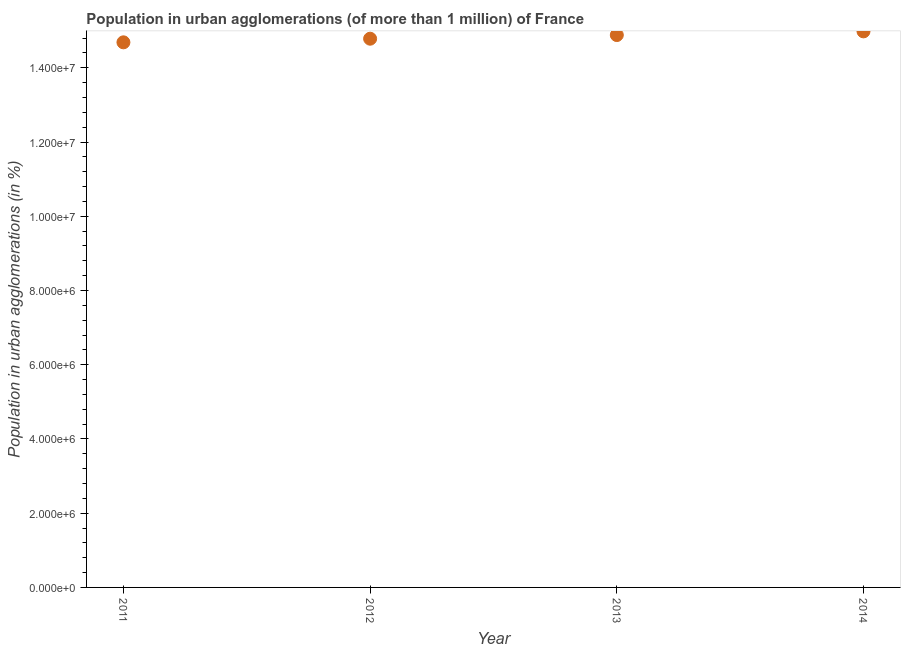What is the population in urban agglomerations in 2012?
Make the answer very short. 1.48e+07. Across all years, what is the maximum population in urban agglomerations?
Offer a very short reply. 1.50e+07. Across all years, what is the minimum population in urban agglomerations?
Offer a very short reply. 1.47e+07. In which year was the population in urban agglomerations maximum?
Provide a short and direct response. 2014. What is the sum of the population in urban agglomerations?
Ensure brevity in your answer.  5.93e+07. What is the difference between the population in urban agglomerations in 2011 and 2013?
Your answer should be compact. -1.96e+05. What is the average population in urban agglomerations per year?
Offer a very short reply. 1.48e+07. What is the median population in urban agglomerations?
Give a very brief answer. 1.48e+07. In how many years, is the population in urban agglomerations greater than 2800000 %?
Keep it short and to the point. 4. Do a majority of the years between 2013 and 2014 (inclusive) have population in urban agglomerations greater than 10400000 %?
Give a very brief answer. Yes. What is the ratio of the population in urban agglomerations in 2012 to that in 2013?
Offer a terse response. 0.99. What is the difference between the highest and the second highest population in urban agglomerations?
Your response must be concise. 9.91e+04. Is the sum of the population in urban agglomerations in 2011 and 2014 greater than the maximum population in urban agglomerations across all years?
Provide a short and direct response. Yes. What is the difference between the highest and the lowest population in urban agglomerations?
Your answer should be compact. 2.95e+05. How many dotlines are there?
Your response must be concise. 1. What is the difference between two consecutive major ticks on the Y-axis?
Provide a short and direct response. 2.00e+06. Are the values on the major ticks of Y-axis written in scientific E-notation?
Provide a succinct answer. Yes. Does the graph contain any zero values?
Make the answer very short. No. Does the graph contain grids?
Provide a succinct answer. No. What is the title of the graph?
Offer a terse response. Population in urban agglomerations (of more than 1 million) of France. What is the label or title of the Y-axis?
Offer a terse response. Population in urban agglomerations (in %). What is the Population in urban agglomerations (in %) in 2011?
Your answer should be compact. 1.47e+07. What is the Population in urban agglomerations (in %) in 2012?
Give a very brief answer. 1.48e+07. What is the Population in urban agglomerations (in %) in 2013?
Provide a short and direct response. 1.49e+07. What is the Population in urban agglomerations (in %) in 2014?
Your answer should be very brief. 1.50e+07. What is the difference between the Population in urban agglomerations (in %) in 2011 and 2012?
Provide a succinct answer. -9.77e+04. What is the difference between the Population in urban agglomerations (in %) in 2011 and 2013?
Give a very brief answer. -1.96e+05. What is the difference between the Population in urban agglomerations (in %) in 2011 and 2014?
Provide a succinct answer. -2.95e+05. What is the difference between the Population in urban agglomerations (in %) in 2012 and 2013?
Provide a succinct answer. -9.84e+04. What is the difference between the Population in urban agglomerations (in %) in 2012 and 2014?
Make the answer very short. -1.97e+05. What is the difference between the Population in urban agglomerations (in %) in 2013 and 2014?
Keep it short and to the point. -9.91e+04. What is the ratio of the Population in urban agglomerations (in %) in 2011 to that in 2013?
Ensure brevity in your answer.  0.99. What is the ratio of the Population in urban agglomerations (in %) in 2011 to that in 2014?
Offer a terse response. 0.98. 